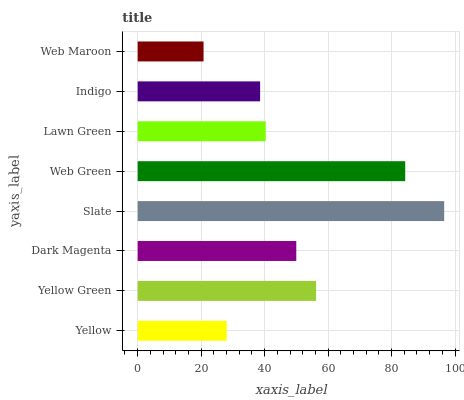Is Web Maroon the minimum?
Answer yes or no. Yes. Is Slate the maximum?
Answer yes or no. Yes. Is Yellow Green the minimum?
Answer yes or no. No. Is Yellow Green the maximum?
Answer yes or no. No. Is Yellow Green greater than Yellow?
Answer yes or no. Yes. Is Yellow less than Yellow Green?
Answer yes or no. Yes. Is Yellow greater than Yellow Green?
Answer yes or no. No. Is Yellow Green less than Yellow?
Answer yes or no. No. Is Dark Magenta the high median?
Answer yes or no. Yes. Is Lawn Green the low median?
Answer yes or no. Yes. Is Indigo the high median?
Answer yes or no. No. Is Web Maroon the low median?
Answer yes or no. No. 